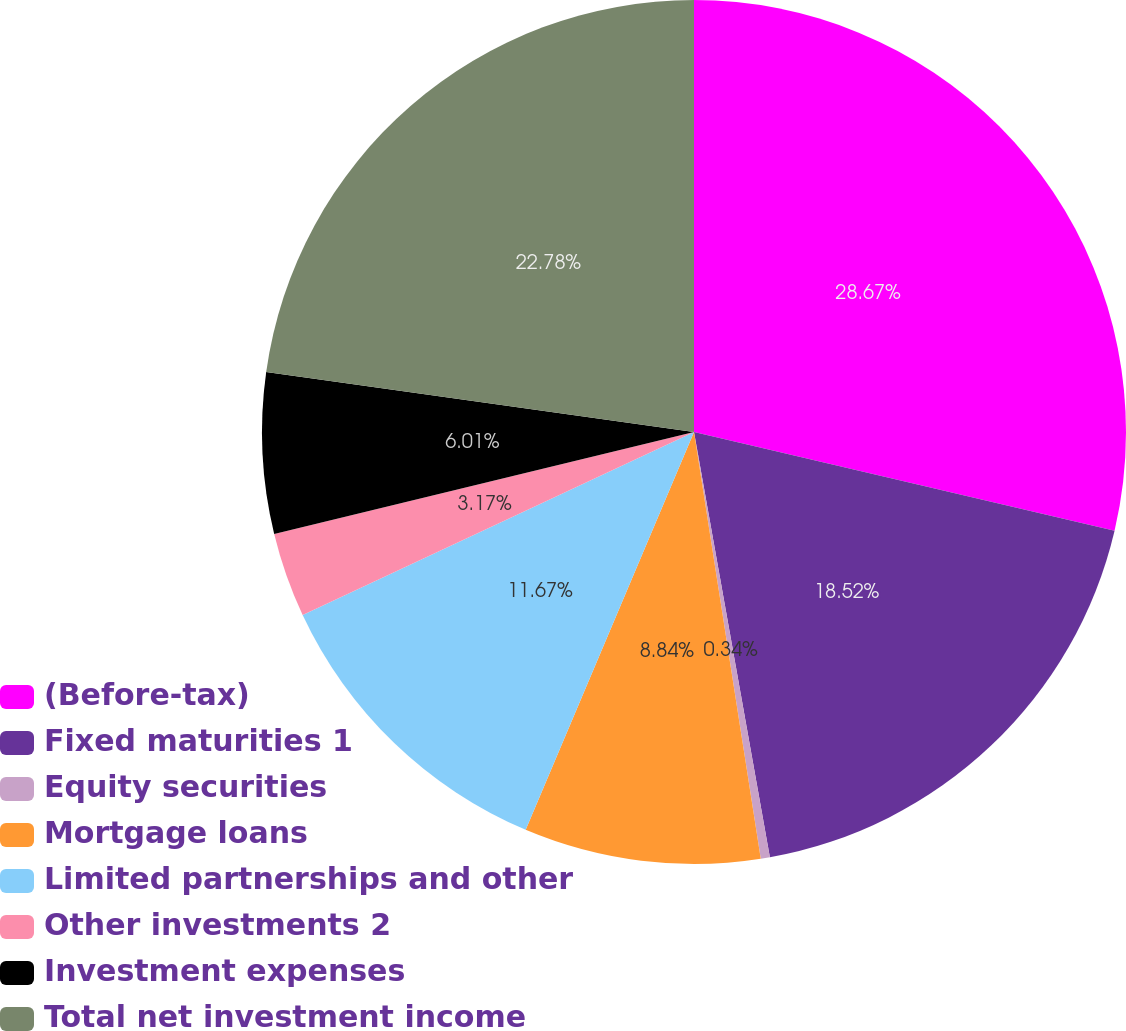<chart> <loc_0><loc_0><loc_500><loc_500><pie_chart><fcel>(Before-tax)<fcel>Fixed maturities 1<fcel>Equity securities<fcel>Mortgage loans<fcel>Limited partnerships and other<fcel>Other investments 2<fcel>Investment expenses<fcel>Total net investment income<nl><fcel>28.67%<fcel>18.52%<fcel>0.34%<fcel>8.84%<fcel>11.67%<fcel>3.17%<fcel>6.01%<fcel>22.78%<nl></chart> 